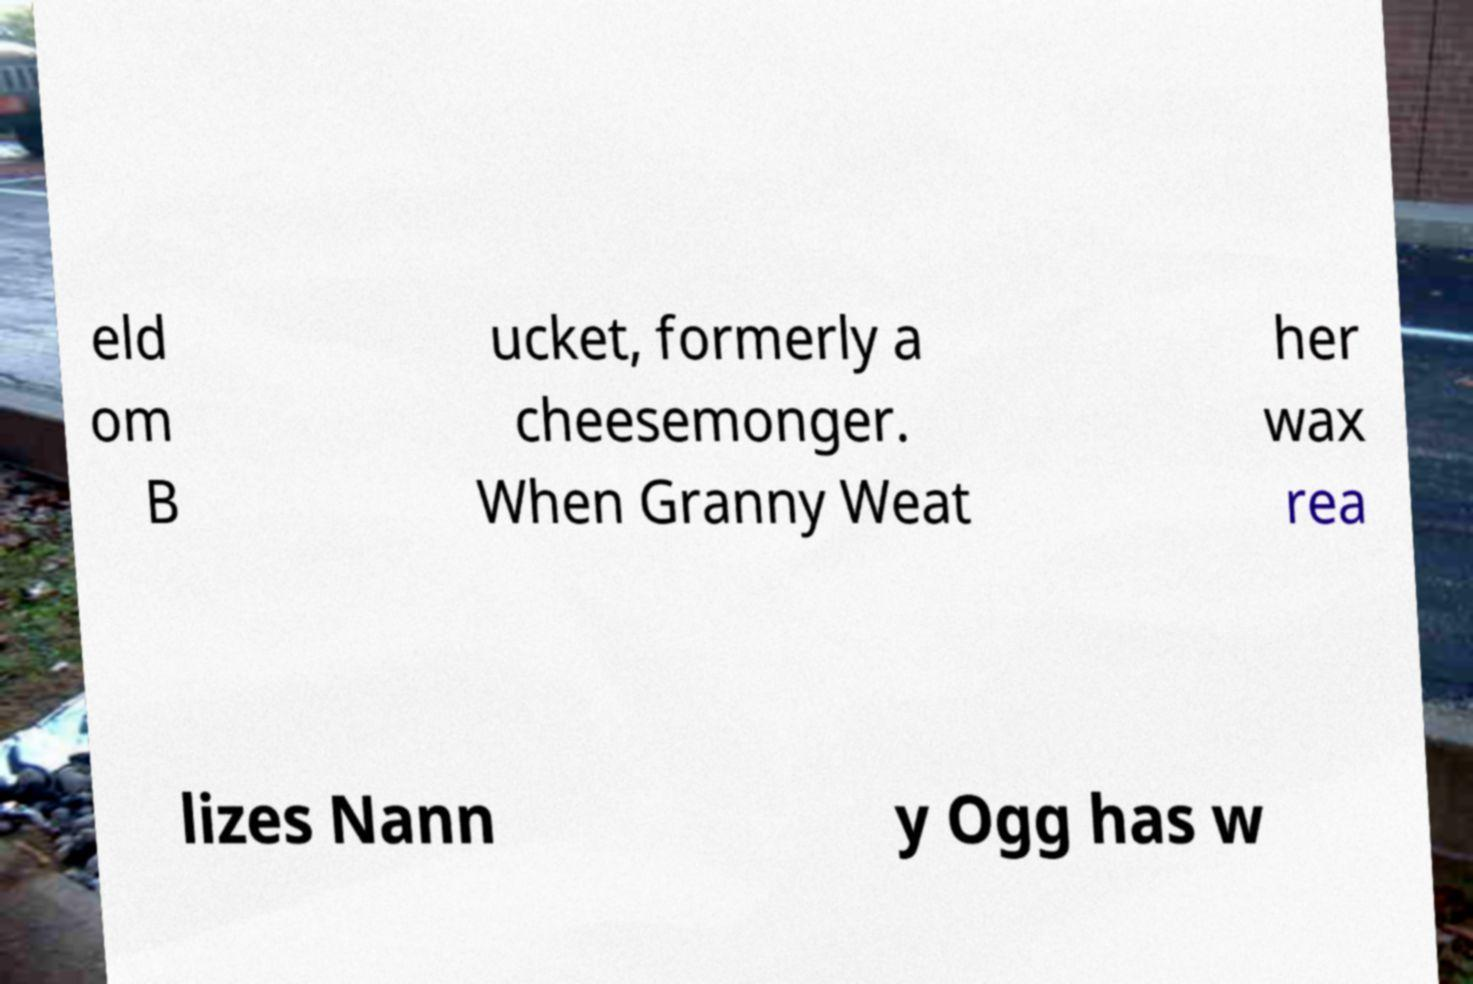There's text embedded in this image that I need extracted. Can you transcribe it verbatim? eld om B ucket, formerly a cheesemonger. When Granny Weat her wax rea lizes Nann y Ogg has w 